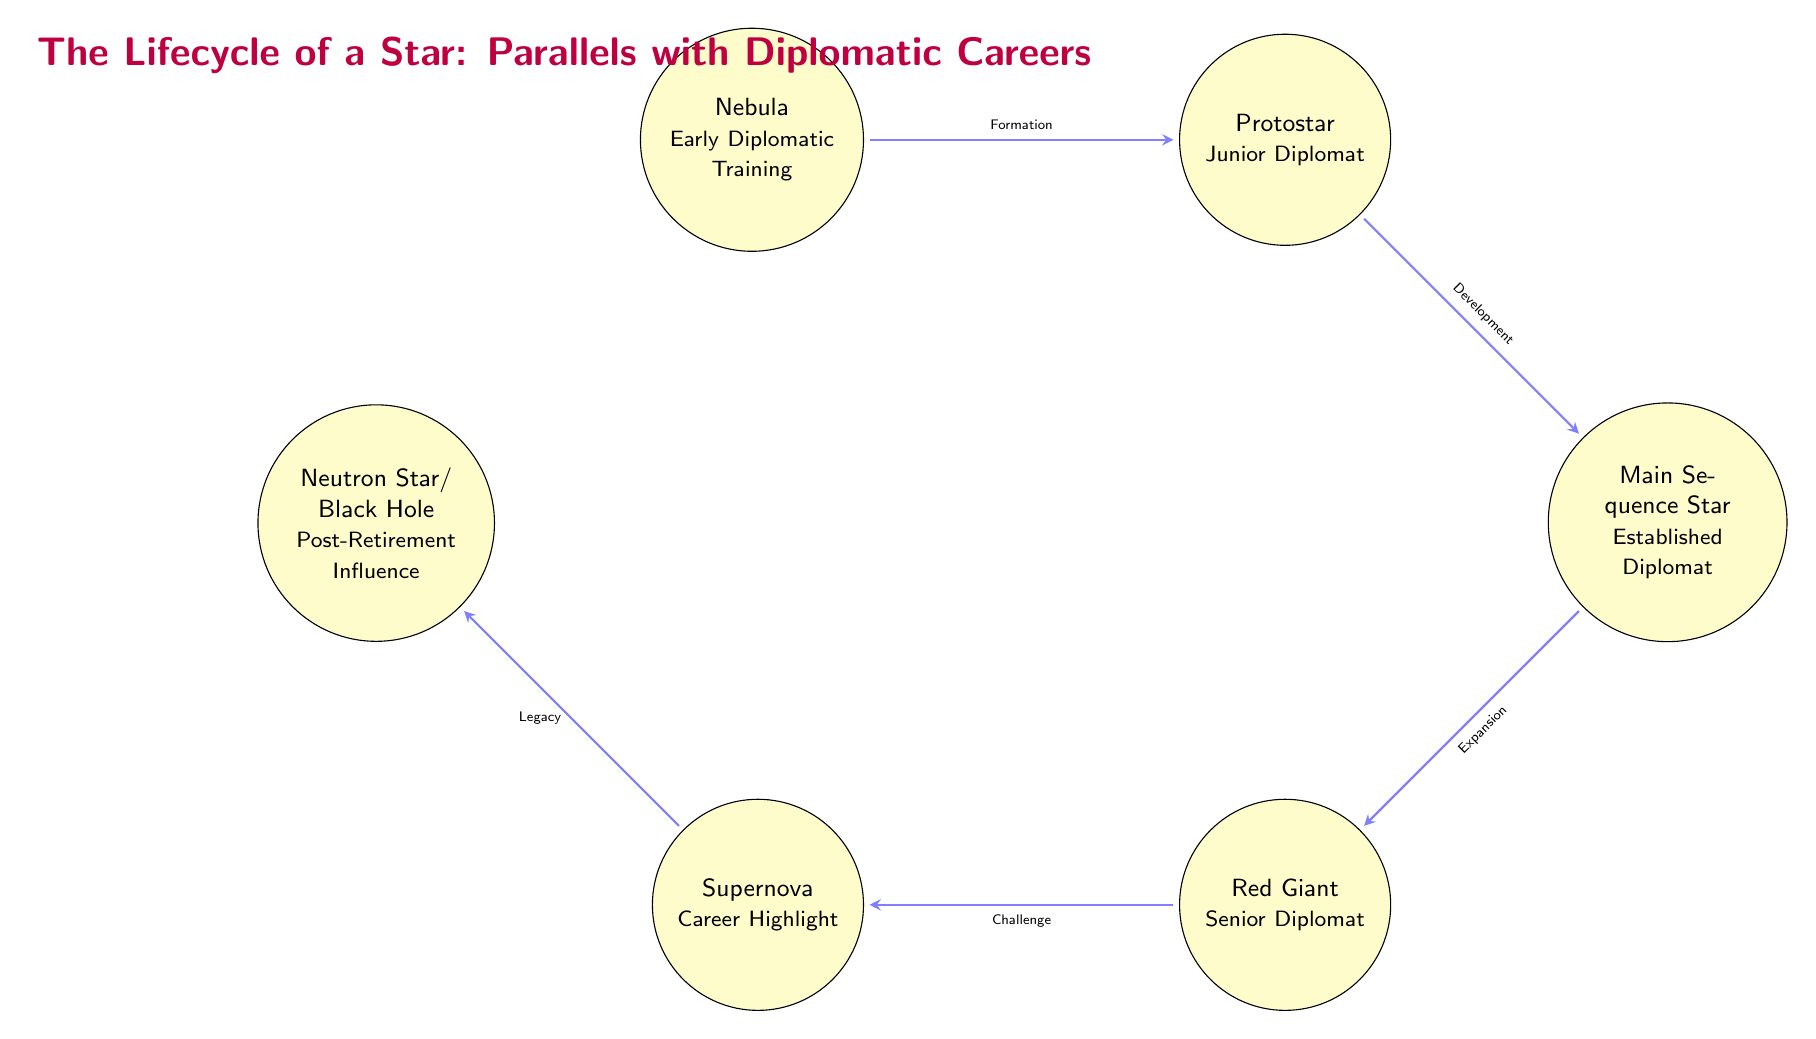What is the first stage of the star's lifecycle? The diagram shows that the first stage is labeled "Nebula," which represents the beginning point of a star's lifecycle.
Answer: Nebula How many stages are represented in the diagram? The diagram features five distinct stages: Nebula, Protostar, Main Sequence Star, Red Giant, and Supernova. Thus, the total count is five.
Answer: 5 What does the arrow from "Nebula" to "Protostar" indicate? The transition edge between these two nodes is labeled "Formation," indicating that it represents the process of transitioning from a Nebula to a Protostar.
Answer: Formation Which stage corresponds to the "Career Highlight"? The stage labeled "Supernova" is associated with "Career Highlight," which suggests it represents a significant milestone in a diplomatic career.
Answer: Supernova What is the significance of the "Neutron Star/ Black Hole" stage? In the context of the diagram, this stage is noted as "Post-Retirement Influence," suggesting that it symbolizes the lasting impact or contribution made after one's active career.
Answer: Post-Retirement Influence What does the arrow between "Main Sequence Star" and "Red Giant" signify? This transition is labeled "Expansion," indicating that it represents a period of growth or broadening in the diplomatic career as one moves from being an established diplomat to a senior diplomat.
Answer: Expansion Which two stages are connected by the label "Challenge"? "Red Giant" and "Supernova" are directly connected by the label "Challenge," showcasing the evolution to a high point in the lifecycle that involves facing significant challenges.
Answer: Red Giant and Supernova What is the relationship between "Protostar" and "Main Sequence Star"? The relationship is described by the transition edge labeled "Development," illustrating how a Protostar evolves into a Main Sequence Star in the lifecycle.
Answer: Development In which stage is the term "Senior Diplomat" used? The stage labeled "Red Giant" is associated with the term "Senior Diplomat," indicating that this phase represents the advanced level in a diplomatic career.
Answer: Red Giant 